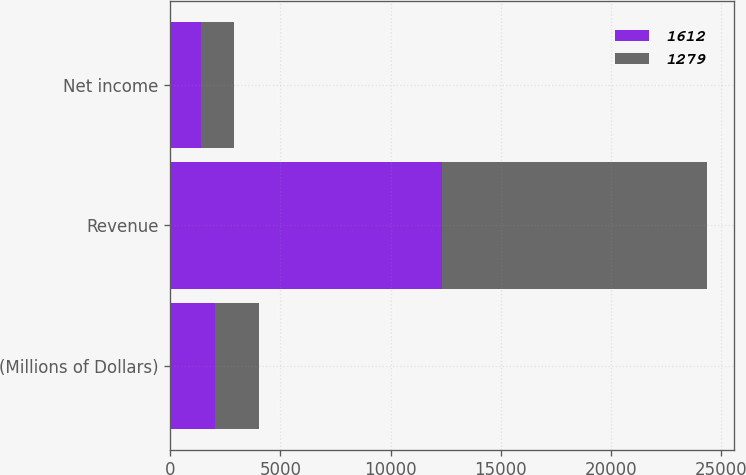Convert chart to OTSL. <chart><loc_0><loc_0><loc_500><loc_500><stacked_bar_chart><ecel><fcel>(Millions of Dollars)<fcel>Revenue<fcel>Net income<nl><fcel>1612<fcel>2018<fcel>12337<fcel>1382<nl><fcel>1279<fcel>2017<fcel>12033<fcel>1525<nl></chart> 